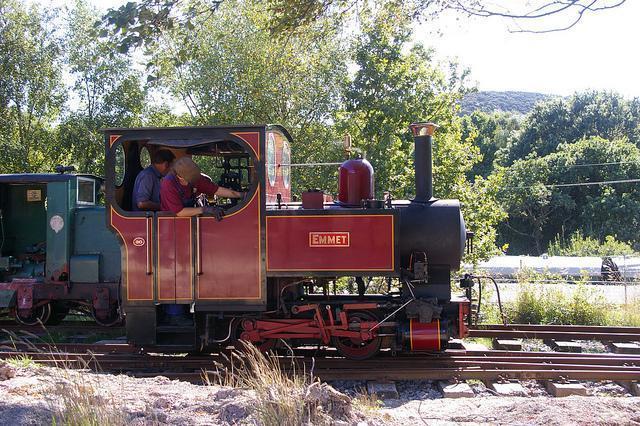How many benches are there?
Give a very brief answer. 0. 